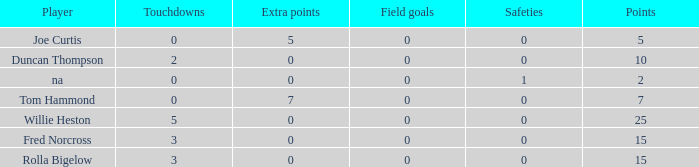How many Touchdowns have a Player of rolla bigelow, and an Extra points smaller than 0? None. 